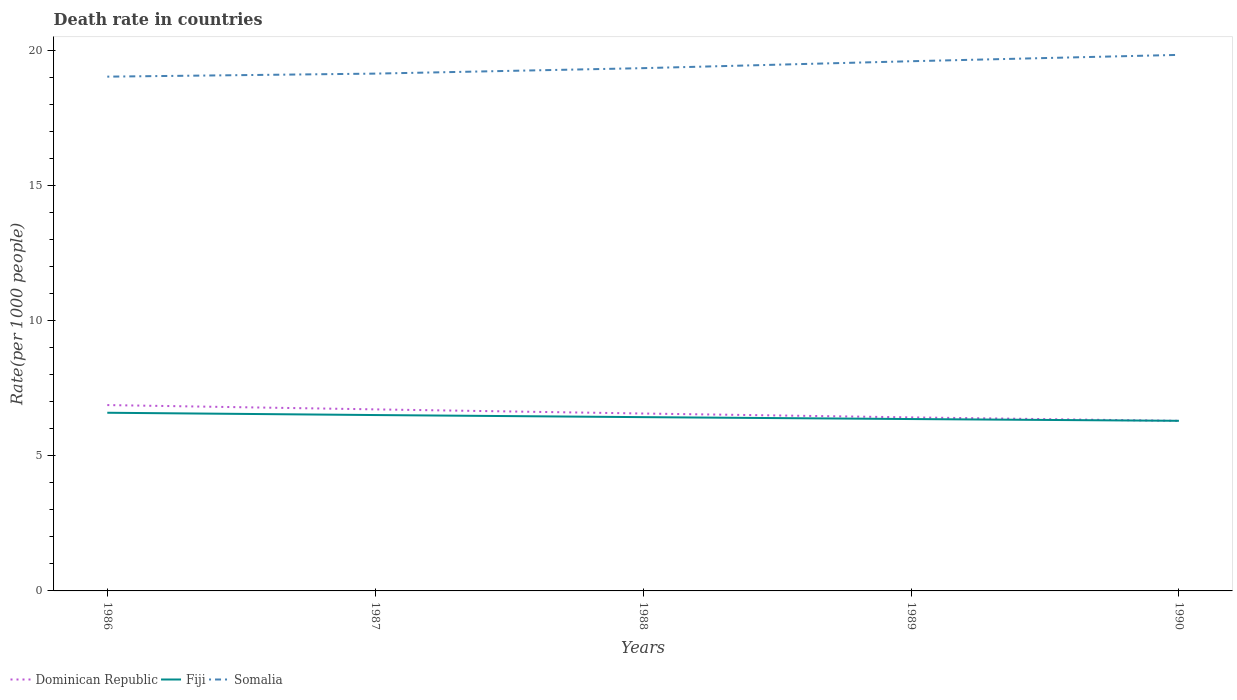How many different coloured lines are there?
Your answer should be very brief. 3. Is the number of lines equal to the number of legend labels?
Your response must be concise. Yes. Across all years, what is the maximum death rate in Somalia?
Give a very brief answer. 19.02. In which year was the death rate in Fiji maximum?
Ensure brevity in your answer.  1990. What is the total death rate in Fiji in the graph?
Your answer should be very brief. 0.08. What is the difference between the highest and the second highest death rate in Dominican Republic?
Keep it short and to the point. 0.58. What is the difference between the highest and the lowest death rate in Somalia?
Offer a terse response. 2. Is the death rate in Dominican Republic strictly greater than the death rate in Somalia over the years?
Your answer should be compact. Yes. How many lines are there?
Keep it short and to the point. 3. How many years are there in the graph?
Your answer should be very brief. 5. Are the values on the major ticks of Y-axis written in scientific E-notation?
Provide a short and direct response. No. Does the graph contain any zero values?
Offer a very short reply. No. How many legend labels are there?
Your answer should be very brief. 3. How are the legend labels stacked?
Ensure brevity in your answer.  Horizontal. What is the title of the graph?
Ensure brevity in your answer.  Death rate in countries. What is the label or title of the Y-axis?
Your answer should be compact. Rate(per 1000 people). What is the Rate(per 1000 people) of Dominican Republic in 1986?
Give a very brief answer. 6.87. What is the Rate(per 1000 people) in Fiji in 1986?
Your answer should be compact. 6.59. What is the Rate(per 1000 people) of Somalia in 1986?
Your response must be concise. 19.02. What is the Rate(per 1000 people) of Dominican Republic in 1987?
Give a very brief answer. 6.71. What is the Rate(per 1000 people) in Fiji in 1987?
Your answer should be very brief. 6.5. What is the Rate(per 1000 people) of Somalia in 1987?
Offer a very short reply. 19.13. What is the Rate(per 1000 people) of Dominican Republic in 1988?
Offer a very short reply. 6.56. What is the Rate(per 1000 people) in Fiji in 1988?
Make the answer very short. 6.43. What is the Rate(per 1000 people) in Somalia in 1988?
Your answer should be very brief. 19.33. What is the Rate(per 1000 people) of Dominican Republic in 1989?
Provide a short and direct response. 6.42. What is the Rate(per 1000 people) of Fiji in 1989?
Your answer should be compact. 6.36. What is the Rate(per 1000 people) of Somalia in 1989?
Give a very brief answer. 19.59. What is the Rate(per 1000 people) of Dominican Republic in 1990?
Your answer should be very brief. 6.29. What is the Rate(per 1000 people) in Fiji in 1990?
Provide a succinct answer. 6.29. What is the Rate(per 1000 people) of Somalia in 1990?
Your answer should be compact. 19.82. Across all years, what is the maximum Rate(per 1000 people) of Dominican Republic?
Keep it short and to the point. 6.87. Across all years, what is the maximum Rate(per 1000 people) in Fiji?
Make the answer very short. 6.59. Across all years, what is the maximum Rate(per 1000 people) of Somalia?
Your response must be concise. 19.82. Across all years, what is the minimum Rate(per 1000 people) in Dominican Republic?
Make the answer very short. 6.29. Across all years, what is the minimum Rate(per 1000 people) in Fiji?
Offer a very short reply. 6.29. Across all years, what is the minimum Rate(per 1000 people) in Somalia?
Offer a terse response. 19.02. What is the total Rate(per 1000 people) in Dominican Republic in the graph?
Make the answer very short. 32.85. What is the total Rate(per 1000 people) of Fiji in the graph?
Provide a short and direct response. 32.16. What is the total Rate(per 1000 people) of Somalia in the graph?
Give a very brief answer. 96.88. What is the difference between the Rate(per 1000 people) in Dominican Republic in 1986 and that in 1987?
Provide a short and direct response. 0.16. What is the difference between the Rate(per 1000 people) in Fiji in 1986 and that in 1987?
Your answer should be compact. 0.09. What is the difference between the Rate(per 1000 people) in Somalia in 1986 and that in 1987?
Your answer should be compact. -0.11. What is the difference between the Rate(per 1000 people) of Dominican Republic in 1986 and that in 1988?
Your answer should be compact. 0.31. What is the difference between the Rate(per 1000 people) in Fiji in 1986 and that in 1988?
Your answer should be compact. 0.16. What is the difference between the Rate(per 1000 people) of Somalia in 1986 and that in 1988?
Keep it short and to the point. -0.31. What is the difference between the Rate(per 1000 people) in Dominican Republic in 1986 and that in 1989?
Ensure brevity in your answer.  0.46. What is the difference between the Rate(per 1000 people) in Fiji in 1986 and that in 1989?
Your response must be concise. 0.23. What is the difference between the Rate(per 1000 people) of Somalia in 1986 and that in 1989?
Your answer should be compact. -0.57. What is the difference between the Rate(per 1000 people) in Dominican Republic in 1986 and that in 1990?
Make the answer very short. 0.58. What is the difference between the Rate(per 1000 people) of Fiji in 1986 and that in 1990?
Your answer should be very brief. 0.3. What is the difference between the Rate(per 1000 people) of Somalia in 1986 and that in 1990?
Ensure brevity in your answer.  -0.81. What is the difference between the Rate(per 1000 people) of Dominican Republic in 1987 and that in 1988?
Give a very brief answer. 0.15. What is the difference between the Rate(per 1000 people) of Fiji in 1987 and that in 1988?
Provide a short and direct response. 0.08. What is the difference between the Rate(per 1000 people) in Somalia in 1987 and that in 1988?
Give a very brief answer. -0.2. What is the difference between the Rate(per 1000 people) of Dominican Republic in 1987 and that in 1989?
Your answer should be compact. 0.3. What is the difference between the Rate(per 1000 people) in Fiji in 1987 and that in 1989?
Make the answer very short. 0.15. What is the difference between the Rate(per 1000 people) in Somalia in 1987 and that in 1989?
Offer a very short reply. -0.46. What is the difference between the Rate(per 1000 people) of Dominican Republic in 1987 and that in 1990?
Make the answer very short. 0.42. What is the difference between the Rate(per 1000 people) of Fiji in 1987 and that in 1990?
Offer a very short reply. 0.21. What is the difference between the Rate(per 1000 people) in Somalia in 1987 and that in 1990?
Ensure brevity in your answer.  -0.69. What is the difference between the Rate(per 1000 people) of Dominican Republic in 1988 and that in 1989?
Keep it short and to the point. 0.14. What is the difference between the Rate(per 1000 people) of Fiji in 1988 and that in 1989?
Make the answer very short. 0.07. What is the difference between the Rate(per 1000 people) of Somalia in 1988 and that in 1989?
Your response must be concise. -0.26. What is the difference between the Rate(per 1000 people) of Dominican Republic in 1988 and that in 1990?
Offer a terse response. 0.27. What is the difference between the Rate(per 1000 people) in Fiji in 1988 and that in 1990?
Provide a short and direct response. 0.14. What is the difference between the Rate(per 1000 people) of Somalia in 1988 and that in 1990?
Your answer should be compact. -0.49. What is the difference between the Rate(per 1000 people) in Dominican Republic in 1989 and that in 1990?
Your response must be concise. 0.13. What is the difference between the Rate(per 1000 people) of Fiji in 1989 and that in 1990?
Keep it short and to the point. 0.07. What is the difference between the Rate(per 1000 people) of Somalia in 1989 and that in 1990?
Give a very brief answer. -0.23. What is the difference between the Rate(per 1000 people) of Dominican Republic in 1986 and the Rate(per 1000 people) of Fiji in 1987?
Offer a terse response. 0.37. What is the difference between the Rate(per 1000 people) of Dominican Republic in 1986 and the Rate(per 1000 people) of Somalia in 1987?
Your answer should be very brief. -12.26. What is the difference between the Rate(per 1000 people) in Fiji in 1986 and the Rate(per 1000 people) in Somalia in 1987?
Your response must be concise. -12.54. What is the difference between the Rate(per 1000 people) in Dominican Republic in 1986 and the Rate(per 1000 people) in Fiji in 1988?
Ensure brevity in your answer.  0.45. What is the difference between the Rate(per 1000 people) of Dominican Republic in 1986 and the Rate(per 1000 people) of Somalia in 1988?
Offer a very short reply. -12.46. What is the difference between the Rate(per 1000 people) in Fiji in 1986 and the Rate(per 1000 people) in Somalia in 1988?
Offer a very short reply. -12.74. What is the difference between the Rate(per 1000 people) in Dominican Republic in 1986 and the Rate(per 1000 people) in Fiji in 1989?
Ensure brevity in your answer.  0.52. What is the difference between the Rate(per 1000 people) of Dominican Republic in 1986 and the Rate(per 1000 people) of Somalia in 1989?
Your answer should be very brief. -12.71. What is the difference between the Rate(per 1000 people) in Fiji in 1986 and the Rate(per 1000 people) in Somalia in 1989?
Provide a short and direct response. -13. What is the difference between the Rate(per 1000 people) in Dominican Republic in 1986 and the Rate(per 1000 people) in Fiji in 1990?
Your answer should be compact. 0.58. What is the difference between the Rate(per 1000 people) of Dominican Republic in 1986 and the Rate(per 1000 people) of Somalia in 1990?
Offer a very short reply. -12.95. What is the difference between the Rate(per 1000 people) of Fiji in 1986 and the Rate(per 1000 people) of Somalia in 1990?
Offer a terse response. -13.23. What is the difference between the Rate(per 1000 people) of Dominican Republic in 1987 and the Rate(per 1000 people) of Fiji in 1988?
Your response must be concise. 0.29. What is the difference between the Rate(per 1000 people) of Dominican Republic in 1987 and the Rate(per 1000 people) of Somalia in 1988?
Offer a terse response. -12.62. What is the difference between the Rate(per 1000 people) in Fiji in 1987 and the Rate(per 1000 people) in Somalia in 1988?
Offer a very short reply. -12.83. What is the difference between the Rate(per 1000 people) in Dominican Republic in 1987 and the Rate(per 1000 people) in Fiji in 1989?
Your response must be concise. 0.36. What is the difference between the Rate(per 1000 people) of Dominican Republic in 1987 and the Rate(per 1000 people) of Somalia in 1989?
Ensure brevity in your answer.  -12.87. What is the difference between the Rate(per 1000 people) in Fiji in 1987 and the Rate(per 1000 people) in Somalia in 1989?
Give a very brief answer. -13.08. What is the difference between the Rate(per 1000 people) in Dominican Republic in 1987 and the Rate(per 1000 people) in Fiji in 1990?
Your response must be concise. 0.42. What is the difference between the Rate(per 1000 people) of Dominican Republic in 1987 and the Rate(per 1000 people) of Somalia in 1990?
Make the answer very short. -13.11. What is the difference between the Rate(per 1000 people) in Fiji in 1987 and the Rate(per 1000 people) in Somalia in 1990?
Make the answer very short. -13.32. What is the difference between the Rate(per 1000 people) of Dominican Republic in 1988 and the Rate(per 1000 people) of Fiji in 1989?
Offer a terse response. 0.2. What is the difference between the Rate(per 1000 people) of Dominican Republic in 1988 and the Rate(per 1000 people) of Somalia in 1989?
Provide a short and direct response. -13.03. What is the difference between the Rate(per 1000 people) of Fiji in 1988 and the Rate(per 1000 people) of Somalia in 1989?
Make the answer very short. -13.16. What is the difference between the Rate(per 1000 people) of Dominican Republic in 1988 and the Rate(per 1000 people) of Fiji in 1990?
Offer a very short reply. 0.27. What is the difference between the Rate(per 1000 people) of Dominican Republic in 1988 and the Rate(per 1000 people) of Somalia in 1990?
Your answer should be compact. -13.26. What is the difference between the Rate(per 1000 people) of Fiji in 1988 and the Rate(per 1000 people) of Somalia in 1990?
Provide a succinct answer. -13.39. What is the difference between the Rate(per 1000 people) of Dominican Republic in 1989 and the Rate(per 1000 people) of Fiji in 1990?
Keep it short and to the point. 0.13. What is the difference between the Rate(per 1000 people) in Dominican Republic in 1989 and the Rate(per 1000 people) in Somalia in 1990?
Ensure brevity in your answer.  -13.4. What is the difference between the Rate(per 1000 people) of Fiji in 1989 and the Rate(per 1000 people) of Somalia in 1990?
Provide a short and direct response. -13.47. What is the average Rate(per 1000 people) of Dominican Republic per year?
Give a very brief answer. 6.57. What is the average Rate(per 1000 people) in Fiji per year?
Give a very brief answer. 6.43. What is the average Rate(per 1000 people) in Somalia per year?
Offer a terse response. 19.38. In the year 1986, what is the difference between the Rate(per 1000 people) of Dominican Republic and Rate(per 1000 people) of Fiji?
Offer a terse response. 0.28. In the year 1986, what is the difference between the Rate(per 1000 people) in Dominican Republic and Rate(per 1000 people) in Somalia?
Offer a very short reply. -12.14. In the year 1986, what is the difference between the Rate(per 1000 people) in Fiji and Rate(per 1000 people) in Somalia?
Give a very brief answer. -12.43. In the year 1987, what is the difference between the Rate(per 1000 people) of Dominican Republic and Rate(per 1000 people) of Fiji?
Offer a terse response. 0.21. In the year 1987, what is the difference between the Rate(per 1000 people) in Dominican Republic and Rate(per 1000 people) in Somalia?
Ensure brevity in your answer.  -12.41. In the year 1987, what is the difference between the Rate(per 1000 people) of Fiji and Rate(per 1000 people) of Somalia?
Keep it short and to the point. -12.62. In the year 1988, what is the difference between the Rate(per 1000 people) of Dominican Republic and Rate(per 1000 people) of Fiji?
Your answer should be compact. 0.13. In the year 1988, what is the difference between the Rate(per 1000 people) of Dominican Republic and Rate(per 1000 people) of Somalia?
Make the answer very short. -12.77. In the year 1988, what is the difference between the Rate(per 1000 people) in Fiji and Rate(per 1000 people) in Somalia?
Keep it short and to the point. -12.9. In the year 1989, what is the difference between the Rate(per 1000 people) in Dominican Republic and Rate(per 1000 people) in Fiji?
Offer a terse response. 0.06. In the year 1989, what is the difference between the Rate(per 1000 people) in Dominican Republic and Rate(per 1000 people) in Somalia?
Your response must be concise. -13.17. In the year 1989, what is the difference between the Rate(per 1000 people) in Fiji and Rate(per 1000 people) in Somalia?
Provide a short and direct response. -13.23. In the year 1990, what is the difference between the Rate(per 1000 people) in Dominican Republic and Rate(per 1000 people) in Fiji?
Give a very brief answer. -0. In the year 1990, what is the difference between the Rate(per 1000 people) in Dominican Republic and Rate(per 1000 people) in Somalia?
Your answer should be very brief. -13.53. In the year 1990, what is the difference between the Rate(per 1000 people) of Fiji and Rate(per 1000 people) of Somalia?
Your response must be concise. -13.53. What is the ratio of the Rate(per 1000 people) in Dominican Republic in 1986 to that in 1987?
Your answer should be very brief. 1.02. What is the ratio of the Rate(per 1000 people) of Fiji in 1986 to that in 1987?
Give a very brief answer. 1.01. What is the ratio of the Rate(per 1000 people) of Dominican Republic in 1986 to that in 1988?
Keep it short and to the point. 1.05. What is the ratio of the Rate(per 1000 people) in Fiji in 1986 to that in 1988?
Offer a very short reply. 1.03. What is the ratio of the Rate(per 1000 people) of Somalia in 1986 to that in 1988?
Offer a very short reply. 0.98. What is the ratio of the Rate(per 1000 people) in Dominican Republic in 1986 to that in 1989?
Your answer should be compact. 1.07. What is the ratio of the Rate(per 1000 people) in Fiji in 1986 to that in 1989?
Your response must be concise. 1.04. What is the ratio of the Rate(per 1000 people) of Somalia in 1986 to that in 1989?
Offer a terse response. 0.97. What is the ratio of the Rate(per 1000 people) of Dominican Republic in 1986 to that in 1990?
Give a very brief answer. 1.09. What is the ratio of the Rate(per 1000 people) of Fiji in 1986 to that in 1990?
Make the answer very short. 1.05. What is the ratio of the Rate(per 1000 people) in Somalia in 1986 to that in 1990?
Provide a succinct answer. 0.96. What is the ratio of the Rate(per 1000 people) of Dominican Republic in 1987 to that in 1988?
Make the answer very short. 1.02. What is the ratio of the Rate(per 1000 people) of Dominican Republic in 1987 to that in 1989?
Offer a very short reply. 1.05. What is the ratio of the Rate(per 1000 people) of Fiji in 1987 to that in 1989?
Ensure brevity in your answer.  1.02. What is the ratio of the Rate(per 1000 people) of Somalia in 1987 to that in 1989?
Your answer should be compact. 0.98. What is the ratio of the Rate(per 1000 people) of Dominican Republic in 1987 to that in 1990?
Make the answer very short. 1.07. What is the ratio of the Rate(per 1000 people) of Fiji in 1987 to that in 1990?
Ensure brevity in your answer.  1.03. What is the ratio of the Rate(per 1000 people) of Dominican Republic in 1988 to that in 1989?
Give a very brief answer. 1.02. What is the ratio of the Rate(per 1000 people) in Fiji in 1988 to that in 1989?
Your answer should be very brief. 1.01. What is the ratio of the Rate(per 1000 people) in Somalia in 1988 to that in 1989?
Provide a short and direct response. 0.99. What is the ratio of the Rate(per 1000 people) of Dominican Republic in 1988 to that in 1990?
Your response must be concise. 1.04. What is the ratio of the Rate(per 1000 people) of Fiji in 1988 to that in 1990?
Provide a succinct answer. 1.02. What is the ratio of the Rate(per 1000 people) of Somalia in 1988 to that in 1990?
Your answer should be very brief. 0.98. What is the ratio of the Rate(per 1000 people) in Dominican Republic in 1989 to that in 1990?
Make the answer very short. 1.02. What is the ratio of the Rate(per 1000 people) of Fiji in 1989 to that in 1990?
Offer a terse response. 1.01. What is the difference between the highest and the second highest Rate(per 1000 people) of Dominican Republic?
Offer a terse response. 0.16. What is the difference between the highest and the second highest Rate(per 1000 people) in Fiji?
Offer a terse response. 0.09. What is the difference between the highest and the second highest Rate(per 1000 people) of Somalia?
Your answer should be compact. 0.23. What is the difference between the highest and the lowest Rate(per 1000 people) of Dominican Republic?
Provide a short and direct response. 0.58. What is the difference between the highest and the lowest Rate(per 1000 people) of Fiji?
Your answer should be compact. 0.3. What is the difference between the highest and the lowest Rate(per 1000 people) in Somalia?
Offer a terse response. 0.81. 